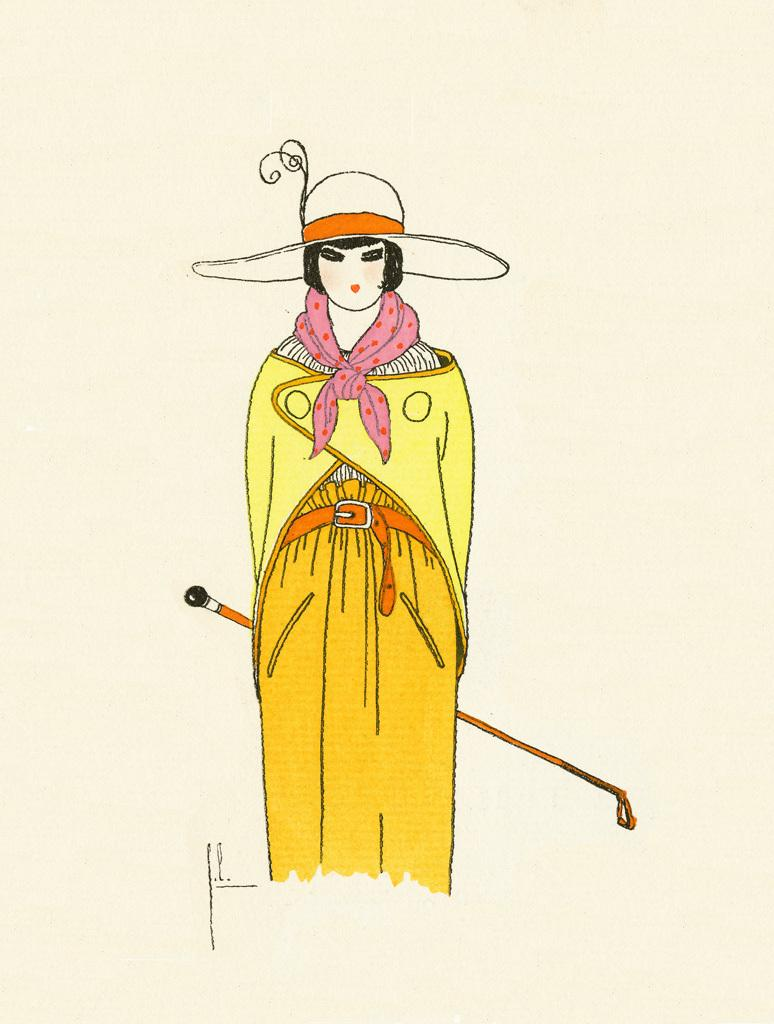What is the main subject of the image? The main subject of the image is a person standing. Can you describe the person in the image? The person is depicted as a woman. What is the woman holding in the image? The woman is holding a stick. What type of trouble can be seen in the image? There is no trouble depicted in the image; it features a woman standing and holding a stick. What type of industry is represented in the image? There is no industry represented in the image; it only shows a woman standing and holding a stick. 